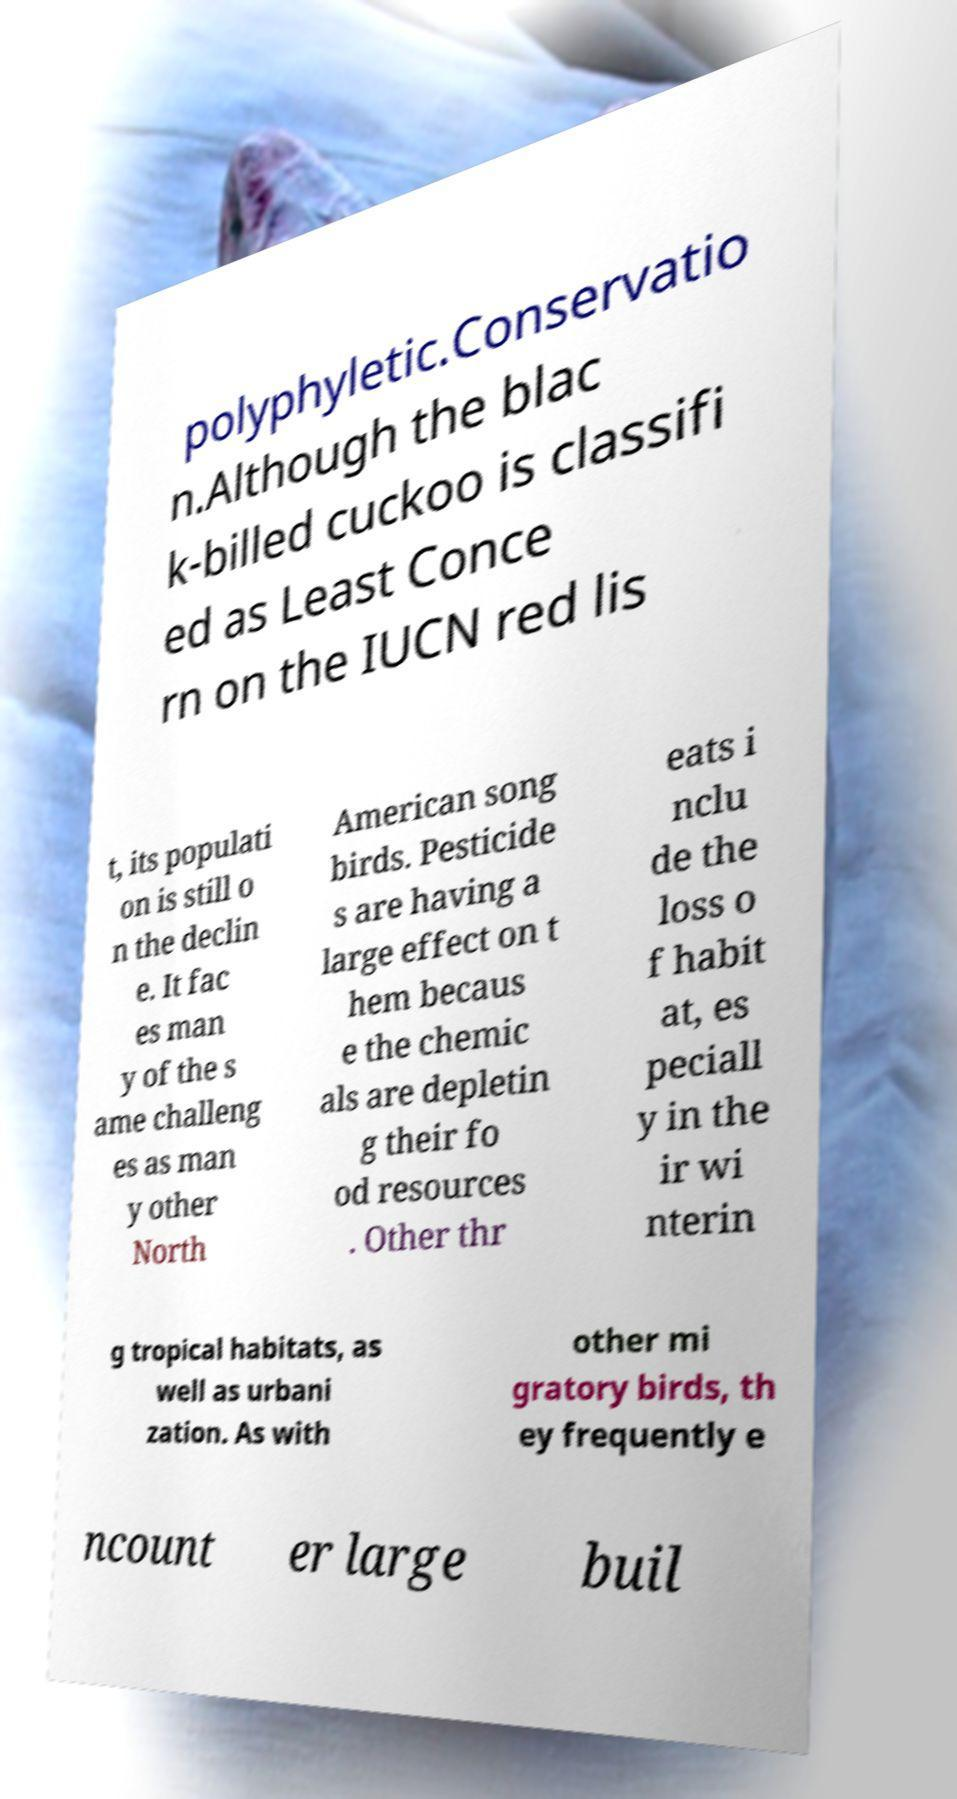Could you assist in decoding the text presented in this image and type it out clearly? polyphyletic.Conservatio n.Although the blac k-billed cuckoo is classifi ed as Least Conce rn on the IUCN red lis t, its populati on is still o n the declin e. It fac es man y of the s ame challeng es as man y other North American song birds. Pesticide s are having a large effect on t hem becaus e the chemic als are depletin g their fo od resources . Other thr eats i nclu de the loss o f habit at, es peciall y in the ir wi nterin g tropical habitats, as well as urbani zation. As with other mi gratory birds, th ey frequently e ncount er large buil 